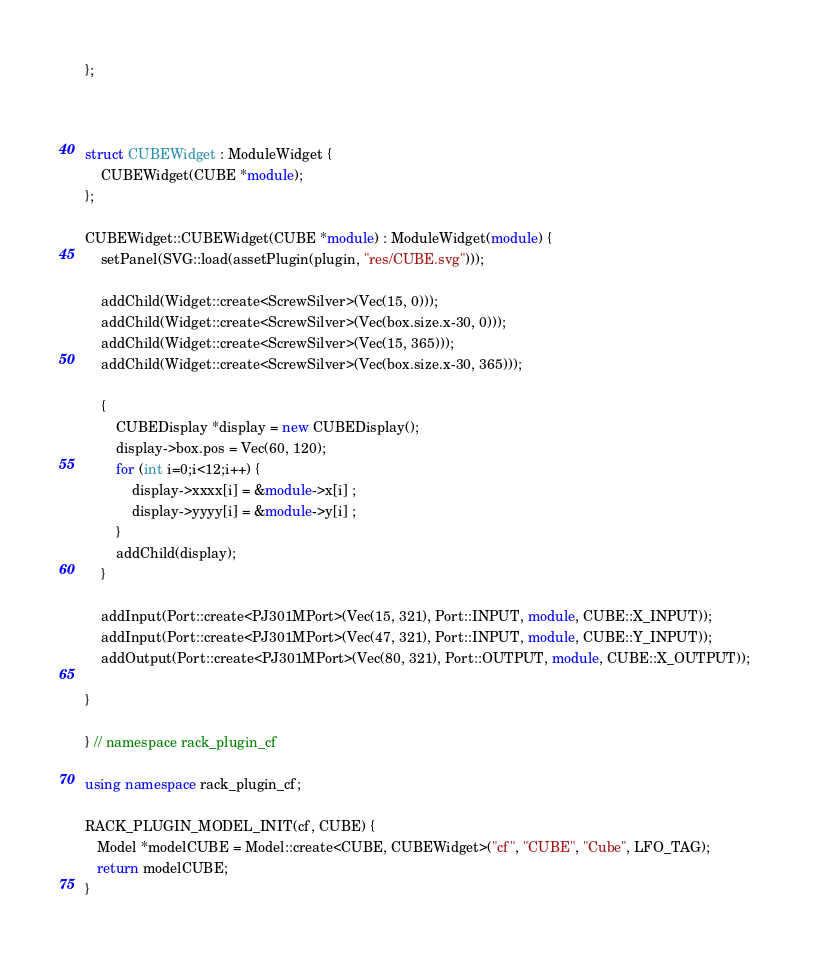<code> <loc_0><loc_0><loc_500><loc_500><_C++_>};



struct CUBEWidget : ModuleWidget {
	CUBEWidget(CUBE *module);
};

CUBEWidget::CUBEWidget(CUBE *module) : ModuleWidget(module) {
	setPanel(SVG::load(assetPlugin(plugin, "res/CUBE.svg")));

	addChild(Widget::create<ScrewSilver>(Vec(15, 0)));
	addChild(Widget::create<ScrewSilver>(Vec(box.size.x-30, 0)));
	addChild(Widget::create<ScrewSilver>(Vec(15, 365)));
	addChild(Widget::create<ScrewSilver>(Vec(box.size.x-30, 365)));

	{
		CUBEDisplay *display = new CUBEDisplay();
		display->box.pos = Vec(60, 120);
		for (int i=0;i<12;i++) {
			display->xxxx[i] = &module->x[i] ;
			display->yyyy[i] = &module->y[i] ;	
		}
		addChild(display);
	}

	addInput(Port::create<PJ301MPort>(Vec(15, 321), Port::INPUT, module, CUBE::X_INPUT));
	addInput(Port::create<PJ301MPort>(Vec(47, 321), Port::INPUT, module, CUBE::Y_INPUT));
	addOutput(Port::create<PJ301MPort>(Vec(80, 321), Port::OUTPUT, module, CUBE::X_OUTPUT));       
	
}

} // namespace rack_plugin_cf

using namespace rack_plugin_cf;

RACK_PLUGIN_MODEL_INIT(cf, CUBE) {
   Model *modelCUBE = Model::create<CUBE, CUBEWidget>("cf", "CUBE", "Cube", LFO_TAG);
   return modelCUBE;
}
</code> 